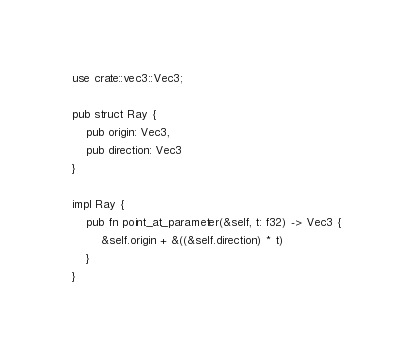Convert code to text. <code><loc_0><loc_0><loc_500><loc_500><_Rust_>use crate::vec3::Vec3;

pub struct Ray {
    pub origin: Vec3,
    pub direction: Vec3
}

impl Ray {
    pub fn point_at_parameter(&self, t: f32) -> Vec3 {
        &self.origin + &((&self.direction) * t)
    }
}
</code> 